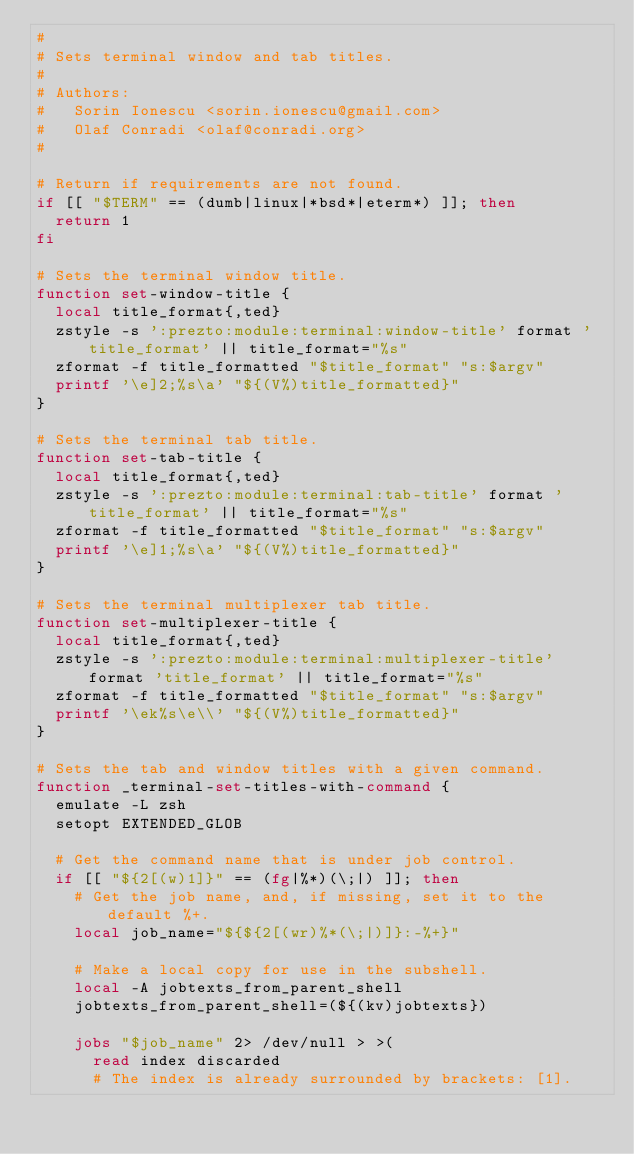Convert code to text. <code><loc_0><loc_0><loc_500><loc_500><_Bash_>#
# Sets terminal window and tab titles.
#
# Authors:
#   Sorin Ionescu <sorin.ionescu@gmail.com>
#   Olaf Conradi <olaf@conradi.org>
#

# Return if requirements are not found.
if [[ "$TERM" == (dumb|linux|*bsd*|eterm*) ]]; then
  return 1
fi

# Sets the terminal window title.
function set-window-title {
  local title_format{,ted}
  zstyle -s ':prezto:module:terminal:window-title' format 'title_format' || title_format="%s"
  zformat -f title_formatted "$title_format" "s:$argv"
  printf '\e]2;%s\a' "${(V%)title_formatted}"
}

# Sets the terminal tab title.
function set-tab-title {
  local title_format{,ted}
  zstyle -s ':prezto:module:terminal:tab-title' format 'title_format' || title_format="%s"
  zformat -f title_formatted "$title_format" "s:$argv"
  printf '\e]1;%s\a' "${(V%)title_formatted}"
}

# Sets the terminal multiplexer tab title.
function set-multiplexer-title {
  local title_format{,ted}
  zstyle -s ':prezto:module:terminal:multiplexer-title' format 'title_format' || title_format="%s"
  zformat -f title_formatted "$title_format" "s:$argv"
  printf '\ek%s\e\\' "${(V%)title_formatted}"
}

# Sets the tab and window titles with a given command.
function _terminal-set-titles-with-command {
  emulate -L zsh
  setopt EXTENDED_GLOB

  # Get the command name that is under job control.
  if [[ "${2[(w)1]}" == (fg|%*)(\;|) ]]; then
    # Get the job name, and, if missing, set it to the default %+.
    local job_name="${${2[(wr)%*(\;|)]}:-%+}"

    # Make a local copy for use in the subshell.
    local -A jobtexts_from_parent_shell
    jobtexts_from_parent_shell=(${(kv)jobtexts})

    jobs "$job_name" 2> /dev/null > >(
      read index discarded
      # The index is already surrounded by brackets: [1].</code> 